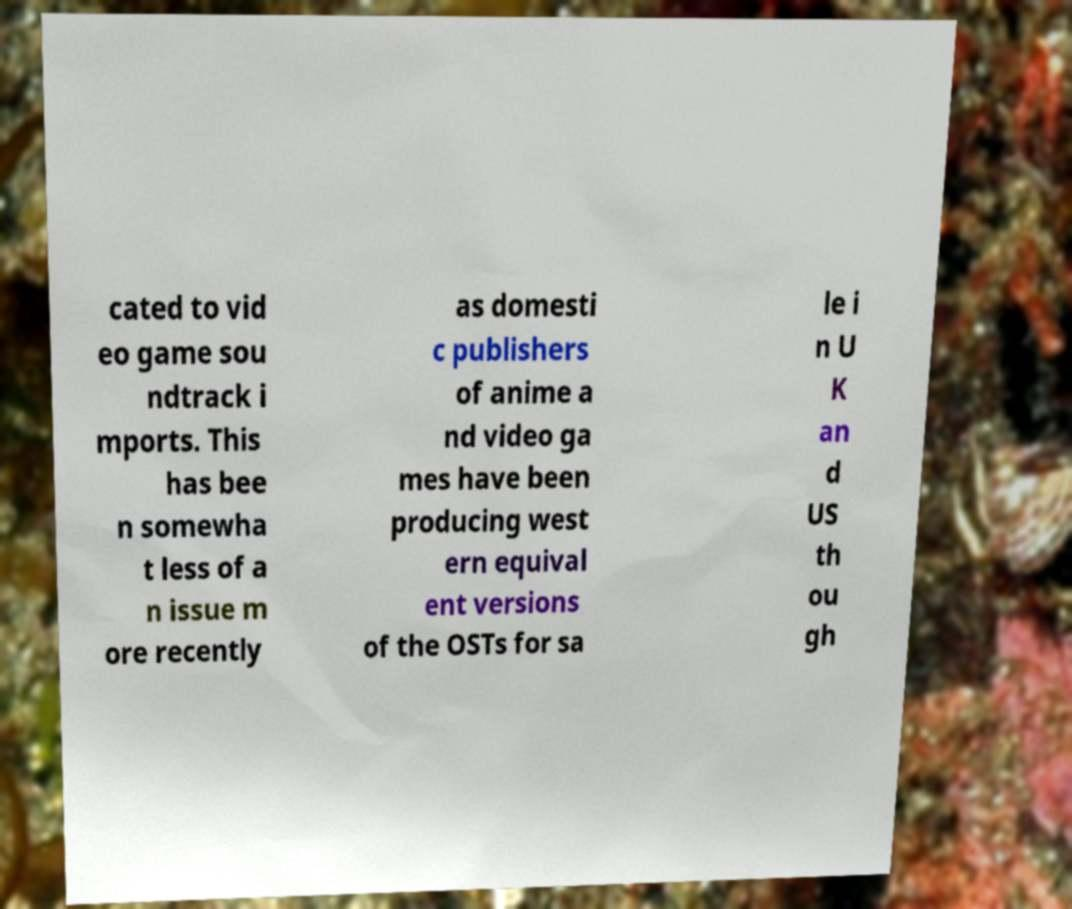Can you read and provide the text displayed in the image?This photo seems to have some interesting text. Can you extract and type it out for me? cated to vid eo game sou ndtrack i mports. This has bee n somewha t less of a n issue m ore recently as domesti c publishers of anime a nd video ga mes have been producing west ern equival ent versions of the OSTs for sa le i n U K an d US th ou gh 